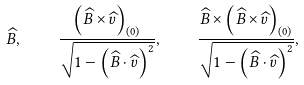Convert formula to latex. <formula><loc_0><loc_0><loc_500><loc_500>\widehat { B } , \quad \frac { \left ( \widehat { B } \times \widehat { v } \right ) _ { ( 0 ) } } { \sqrt { 1 - \left ( \widehat { B } \cdot \widehat { v } \right ) ^ { 2 } } } , \quad \frac { \widehat { B } \times \left ( \widehat { B } \times \widehat { v } \right ) _ { ( 0 ) } } { \sqrt { 1 - \left ( \widehat { B } \cdot \widehat { v } \right ) ^ { 2 } } } ,</formula> 